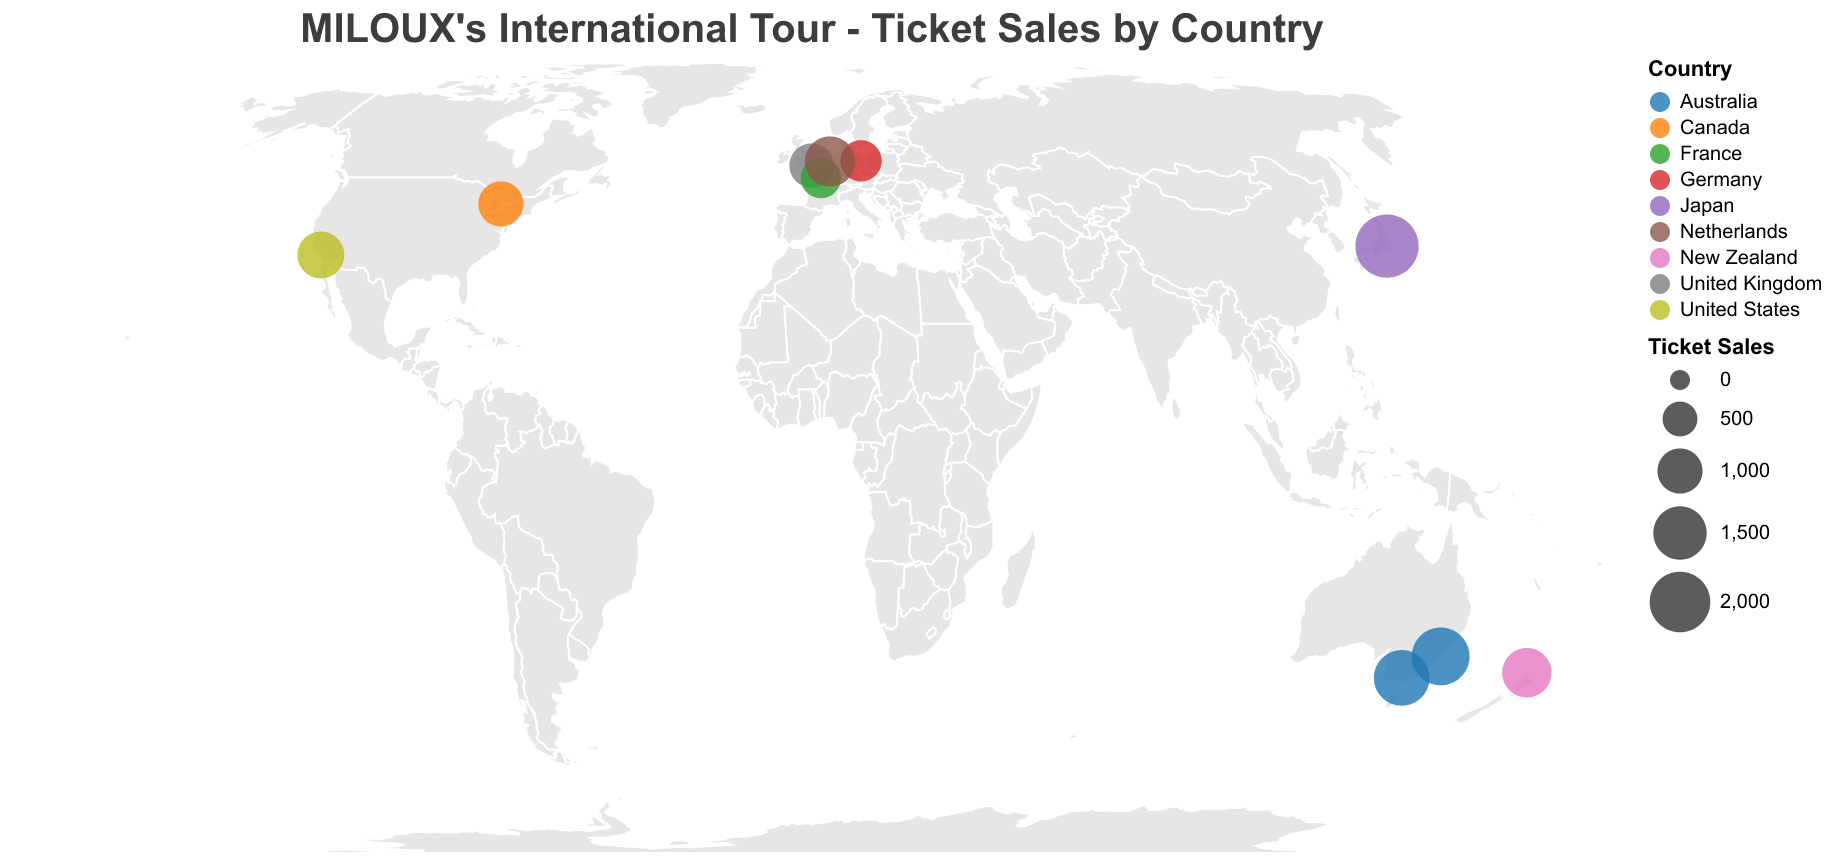Which country has the highest ticket sales for MILOUX's tour? By examining the figure, we can see the relative sizes of the circles indicating ticket sales across countries. The largest circle is located in Tokyo, Japan. The tooltip also confirms that Japan has ticket sales of 2200, which is the highest.
Answer: Japan How many countries did MILOUX visit on this tour? The figure highlights different countries using distinct colors and labels. Counting these countries, we have New Zealand, Australia, Japan, United States, United Kingdom, Germany, France, Canada, and Netherlands, making a total of 9 countries.
Answer: 9 What are the total ticket sales in Australia? The figure shows two locations in Australia: Sydney (1800 tickets) and Melbourne (1650 tickets). Summing these up gives 1800 + 1650 = 3450 tickets.
Answer: 3450 Which venue in Europe had the lowest ticket sales and how many were sold there? Looking at the European venues (London, Berlin, Paris, Amsterdam), we check their ticket sales: London (950), Berlin (800), Paris (750), Amsterdam (1300). Paris had the lowest ticket sales (750).
Answer: Paris, 750 Which city's venue had fewer ticket sales: Berlin or Toronto? By comparing the ticket sales from the figure, Berlin's venue sold 800 tickets while Toronto's venue sold 1000. Berlin had fewer ticket sales.
Answer: Berlin What is the average ticket sales per venue across all tour locations? Adding up all ticket sales: 
New Zealand (1250), Sydney (1800), Melbourne (1650), Tokyo (2200), Los Angeles (1100), London (950), Berlin (800), Paris (750), Toronto (1000), Amsterdam (1300), we get a sum of 12800 tickets. There are 10 venues, so the average would be 12800 / 10 = 1280 tickets.
Answer: 1280 Which continent had the highest combined ticket sales, and what was the total? Examining ticket sales by continent:
- Oceania: New Zealand (1250) + Australia (3450) = 4700
- Asia: Japan (2200)
- North America: United States (1100) + Canada (1000) = 2100
- Europe: United Kingdom (950) + Germany (800) + France (750) + Netherlands (1300) = 3800
Oceania has the highest combined ticket sales.
Answer: Oceania, 4700 What is the difference in ticket sales between the venue in Tokyo and the venue in Los Angeles? From the figure, Tokyo's venue sold 2200 tickets while Los Angeles' venue sold 1100 tickets. The difference is 2200 - 1100 = 1100 tickets.
Answer: 1100 What is the median ticket sales among the tour locations? Listing the ticket sales in ascending order: 750 (Paris), 800 (Berlin), 950 (London), 1000 (Toronto), 1100 (Los Angeles), 1250 (Auckland), 1300 (Amsterdam), 1650 (Melbourne), 1800 (Sydney), 2200 (Tokyo). With 10 data points, the median is the average of the 5th and 6th values: (1100 + 1250) / 2 = 1175 tickets.
Answer: 1175 